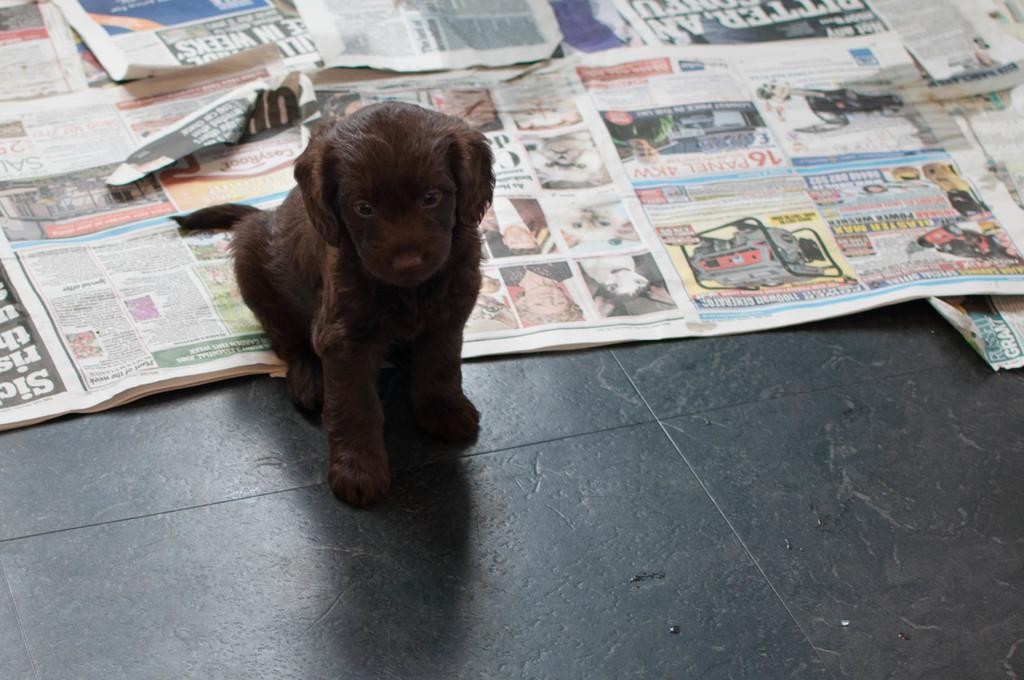What type of animal is present in the image? There is a dog in the image. What color is the dog? The dog is brown in color. What is the dog doing in the image? The dog is spitting on the floor. What color is the floor? The floor is black in color. What else can be seen in the image besides the dog and the floor? There is a newspaper in the image. How many cars are parked at the airport in the image? There is no airport or cars present in the image; it features a dog, a brown dog spitting on a black floor, and a newspaper. 